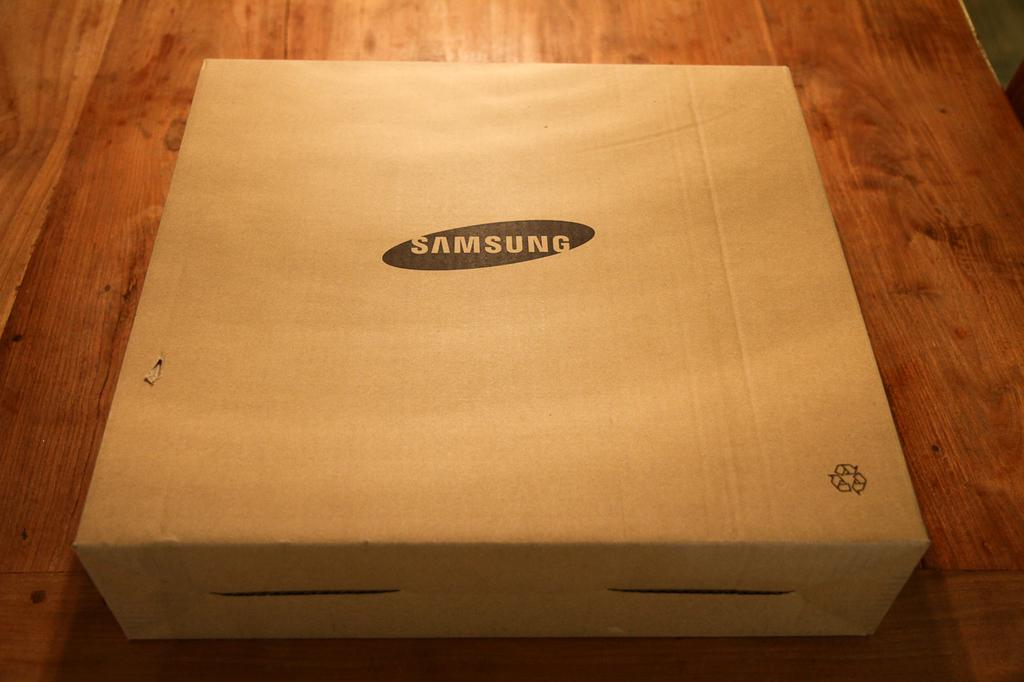What object is present on the wooden surface in the image? There is a box on the wooden surface in the image. What is the material of the surface the box is placed on? The wooden surface is made of wood. What feature can be seen on the box? The box has a logo on it. What type of bead is used to create the logo on the box? There is no mention of a bead being used to create the logo on the box in the image. 